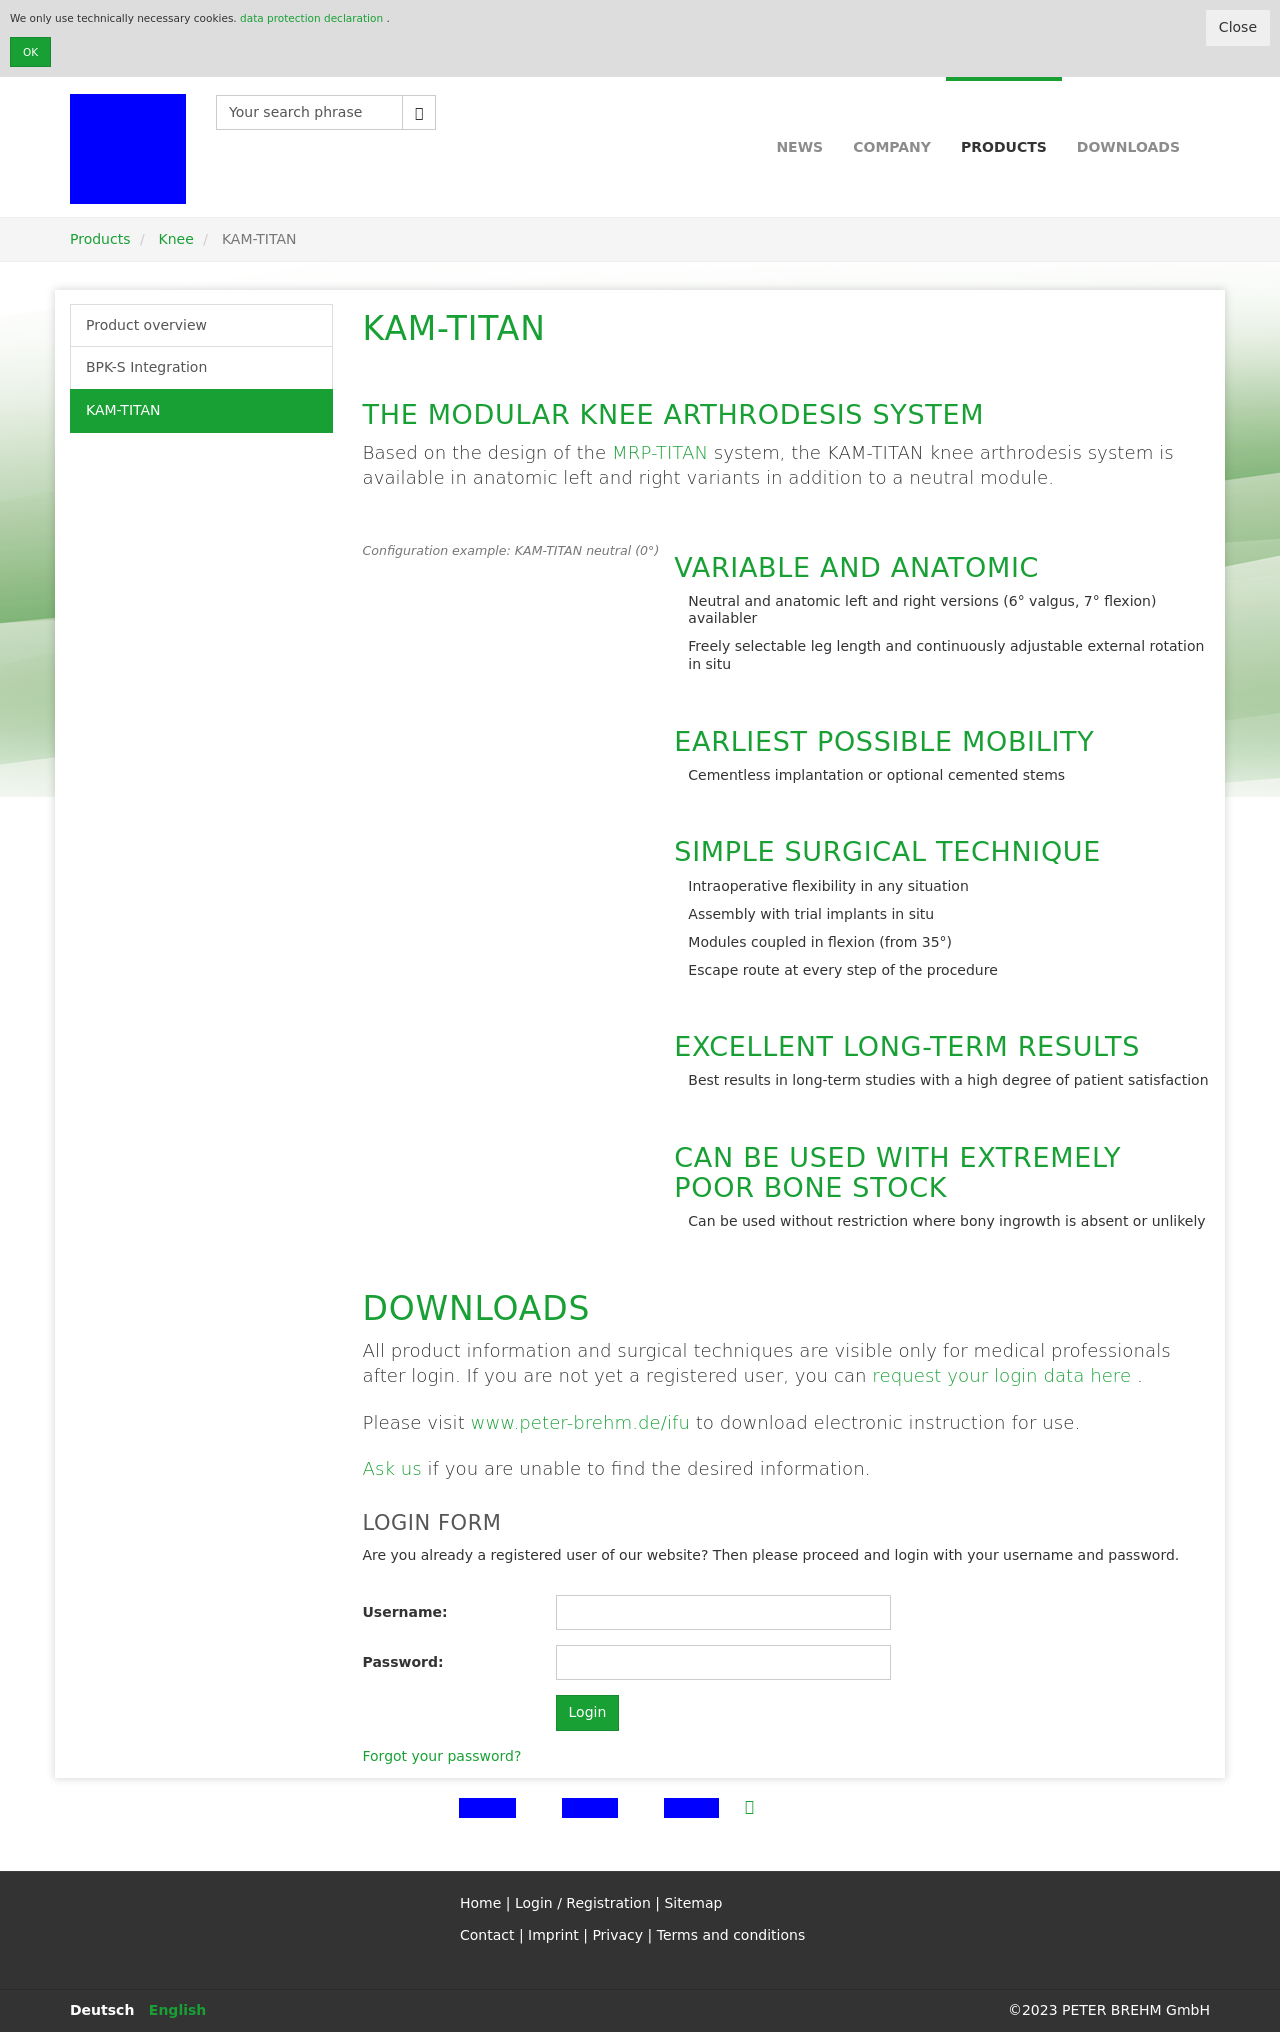Could you detail the process for assembling this website using HTML? The process of building a website like the one shown involves defining the HTML structure and applying CSS for styling. JThe detailed HTML structure sets up elements such as divs for layout management, while the CSS handles everything from layout positions to styling details like fonts and colors. Furthermore, adding interactive components might involve JavaScript to enrich user interactions. Remember to ensure your site is responsive by using media queries in CSS, making sure it displays nicely on devices of all sizes. 